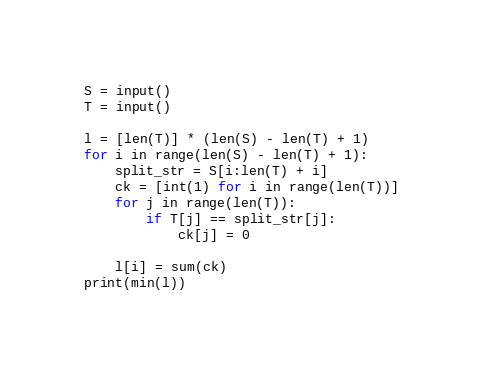<code> <loc_0><loc_0><loc_500><loc_500><_Python_>S = input()
T = input()

l = [len(T)] * (len(S) - len(T) + 1)
for i in range(len(S) - len(T) + 1):
    split_str = S[i:len(T) + i]
    ck = [int(1) for i in range(len(T))]
    for j in range(len(T)):
        if T[j] == split_str[j]:
            ck[j] = 0

    l[i] = sum(ck)
print(min(l))</code> 